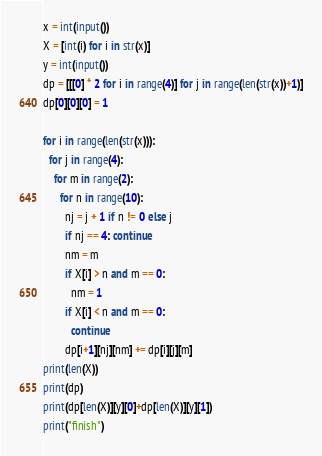<code> <loc_0><loc_0><loc_500><loc_500><_Python_>x = int(input())
X = [int(i) for i in str(x)]
y = int(input())
dp = [[[0] * 2 for i in range(4)] for j in range(len(str(x))+1)]
dp[0][0][0] = 1

for i in range(len(str(x))):
  for j in range(4):
    for m in range(2):
      for n in range(10):
        nj = j + 1 if n != 0 else j
        if nj == 4: continue
        nm = m        
        if X[i] > n and m == 0:
          nm = 1
        if X[i] < n and m == 0:
          continue
        dp[i+1][nj][nm] += dp[i][j][m]
print(len(X))
print(dp)
print(dp[len(X)][y][0]+dp[len(X)][y][1])
print("finish")</code> 